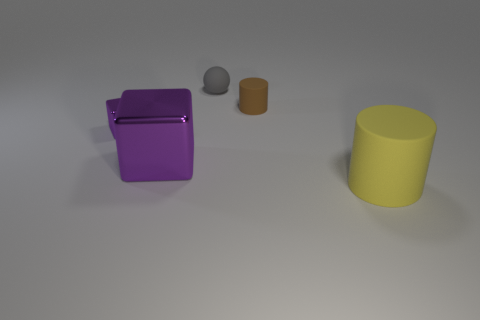What number of other purple objects are the same shape as the tiny purple object?
Your response must be concise. 1. There is a object to the left of the large metal object that is to the left of the yellow cylinder; what color is it?
Ensure brevity in your answer.  Purple. There is a small brown object; is its shape the same as the yellow thing that is on the right side of the small block?
Provide a short and direct response. Yes. The cylinder that is behind the rubber thing that is in front of the cylinder on the left side of the big rubber cylinder is made of what material?
Make the answer very short. Rubber. Is there a yellow rubber cube that has the same size as the yellow cylinder?
Your answer should be very brief. No. What is the size of the brown thing that is the same material as the gray thing?
Your answer should be compact. Small. What shape is the gray rubber object?
Offer a very short reply. Sphere. Do the large yellow thing and the tiny thing that is right of the gray matte object have the same material?
Your answer should be compact. Yes. How many objects are either tiny purple cubes or big rubber things?
Your answer should be very brief. 2. Are any cylinders visible?
Your response must be concise. Yes. 